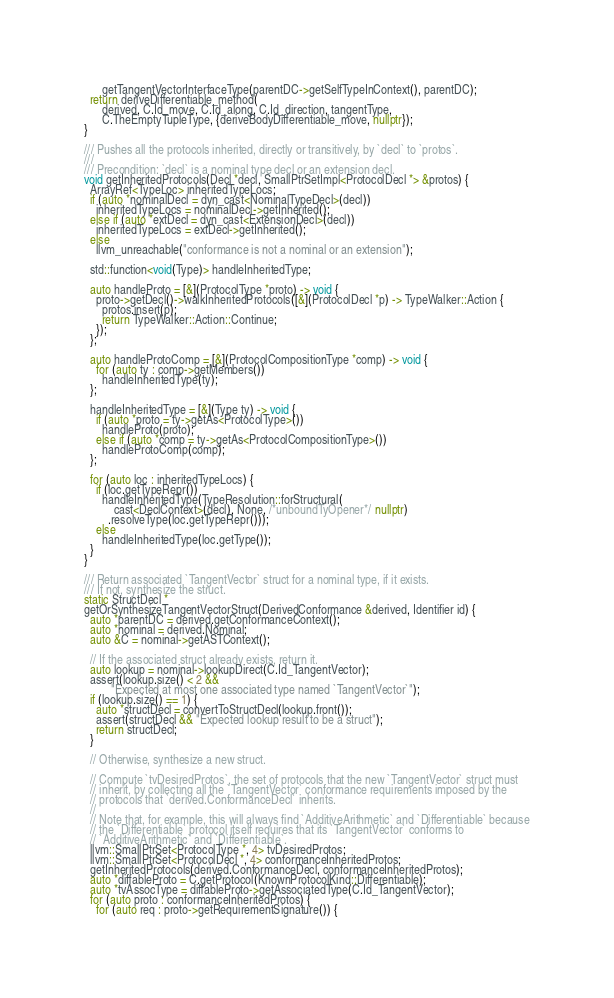<code> <loc_0><loc_0><loc_500><loc_500><_C++_>      getTangentVectorInterfaceType(parentDC->getSelfTypeInContext(), parentDC);
  return deriveDifferentiable_method(
      derived, C.Id_move, C.Id_along, C.Id_direction, tangentType,
      C.TheEmptyTupleType, {deriveBodyDifferentiable_move, nullptr});
}

/// Pushes all the protocols inherited, directly or transitively, by `decl` to `protos`.
///
/// Precondition: `decl` is a nominal type decl or an extension decl.
void getInheritedProtocols(Decl *decl, SmallPtrSetImpl<ProtocolDecl *> &protos) {
  ArrayRef<TypeLoc> inheritedTypeLocs;
  if (auto *nominalDecl = dyn_cast<NominalTypeDecl>(decl))
    inheritedTypeLocs = nominalDecl->getInherited();
  else if (auto *extDecl = dyn_cast<ExtensionDecl>(decl))
    inheritedTypeLocs = extDecl->getInherited();
  else
    llvm_unreachable("conformance is not a nominal or an extension");

  std::function<void(Type)> handleInheritedType;

  auto handleProto = [&](ProtocolType *proto) -> void {
    proto->getDecl()->walkInheritedProtocols([&](ProtocolDecl *p) -> TypeWalker::Action {
      protos.insert(p);
      return TypeWalker::Action::Continue;
    });
  };

  auto handleProtoComp = [&](ProtocolCompositionType *comp) -> void {
    for (auto ty : comp->getMembers())
      handleInheritedType(ty);
  };

  handleInheritedType = [&](Type ty) -> void {
    if (auto *proto = ty->getAs<ProtocolType>())
      handleProto(proto);
    else if (auto *comp = ty->getAs<ProtocolCompositionType>())
      handleProtoComp(comp);
  };

  for (auto loc : inheritedTypeLocs) {
    if (loc.getTypeRepr())
      handleInheritedType(TypeResolution::forStructural(
          cast<DeclContext>(decl), None, /*unboundTyOpener*/ nullptr)
        .resolveType(loc.getTypeRepr()));
    else
      handleInheritedType(loc.getType());
  }
}

/// Return associated `TangentVector` struct for a nominal type, if it exists.
/// If not, synthesize the struct.
static StructDecl *
getOrSynthesizeTangentVectorStruct(DerivedConformance &derived, Identifier id) {
  auto *parentDC = derived.getConformanceContext();
  auto *nominal = derived.Nominal;
  auto &C = nominal->getASTContext();

  // If the associated struct already exists, return it.
  auto lookup = nominal->lookupDirect(C.Id_TangentVector);
  assert(lookup.size() < 2 &&
         "Expected at most one associated type named `TangentVector`");
  if (lookup.size() == 1) {
    auto *structDecl = convertToStructDecl(lookup.front());
    assert(structDecl && "Expected lookup result to be a struct");
    return structDecl;
  }

  // Otherwise, synthesize a new struct.

  // Compute `tvDesiredProtos`, the set of protocols that the new `TangentVector` struct must
  // inherit, by collecting all the `TangentVector` conformance requirements imposed by the
  // protocols that `derived.ConformanceDecl` inherits.
  //
  // Note that, for example, this will always find `AdditiveArithmetic` and `Differentiable` because
  // the `Differentiable` protocol itself requires that its `TangentVector` conforms to
  // `AdditiveArithmetic` and `Differentiable`.
  llvm::SmallPtrSet<ProtocolType *, 4> tvDesiredProtos;
  llvm::SmallPtrSet<ProtocolDecl *, 4> conformanceInheritedProtos;
  getInheritedProtocols(derived.ConformanceDecl, conformanceInheritedProtos);
  auto *diffableProto = C.getProtocol(KnownProtocolKind::Differentiable);
  auto *tvAssocType = diffableProto->getAssociatedType(C.Id_TangentVector);
  for (auto proto : conformanceInheritedProtos) {
    for (auto req : proto->getRequirementSignature()) {</code> 